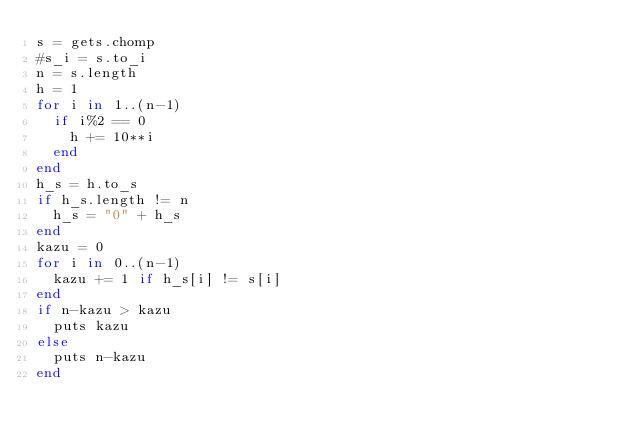<code> <loc_0><loc_0><loc_500><loc_500><_Ruby_>s = gets.chomp
#s_i = s.to_i
n = s.length
h = 1
for i in 1..(n-1)
  if i%2 == 0
    h += 10**i
  end
end
h_s = h.to_s
if h_s.length != n
  h_s = "0" + h_s
end
kazu = 0
for i in 0..(n-1)
  kazu += 1 if h_s[i] != s[i]
end
if n-kazu > kazu
  puts kazu
else
  puts n-kazu
end
</code> 